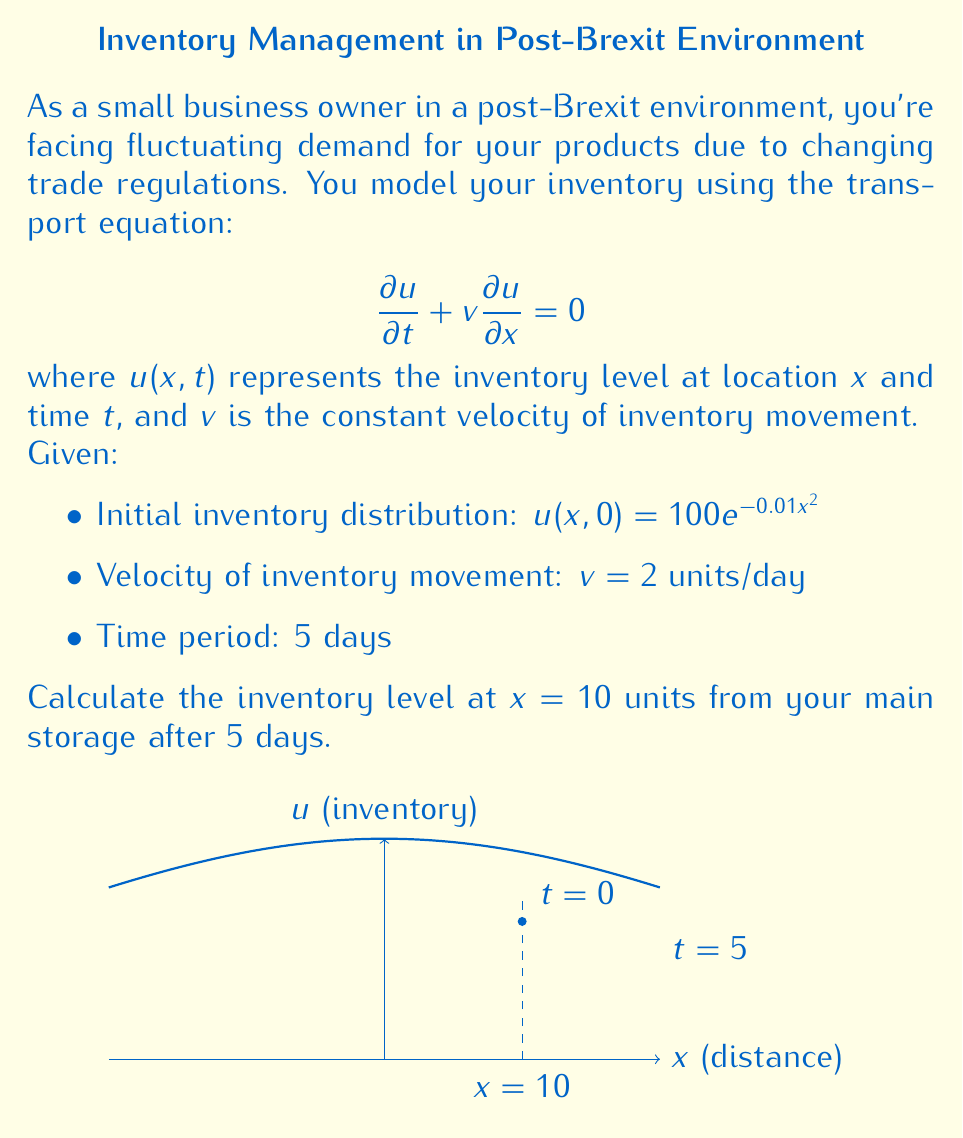Could you help me with this problem? Let's approach this step-by-step using the method of characteristics:

1) The general solution to the transport equation is:
   $$u(x,t) = u_0(x - vt)$$
   where $u_0(x)$ is the initial condition.

2) Our initial condition is:
   $$u_0(x) = 100e^{-0.01x^2}$$

3) Substituting into the general solution:
   $$u(x,t) = 100e^{-0.01(x-vt)^2}$$

4) We're given:
   - $x = 10$ (location)
   - $t = 5$ (time)
   - $v = 2$ (velocity)

5) Substituting these values:
   $$u(10,5) = 100e^{-0.01(10-2*5)^2}$$
   $$= 100e^{-0.01(10-10)^2}$$
   $$= 100e^{-0.01(0)^2}$$
   $$= 100e^0 = 100$$

Therefore, after 5 days, the inventory level at x = 10 units from the main storage will be 100 units.

This result shows that the peak of the inventory distribution has moved exactly to x = 10 after 5 days, which aligns with the velocity of 2 units/day over 5 days.
Answer: 100 units 